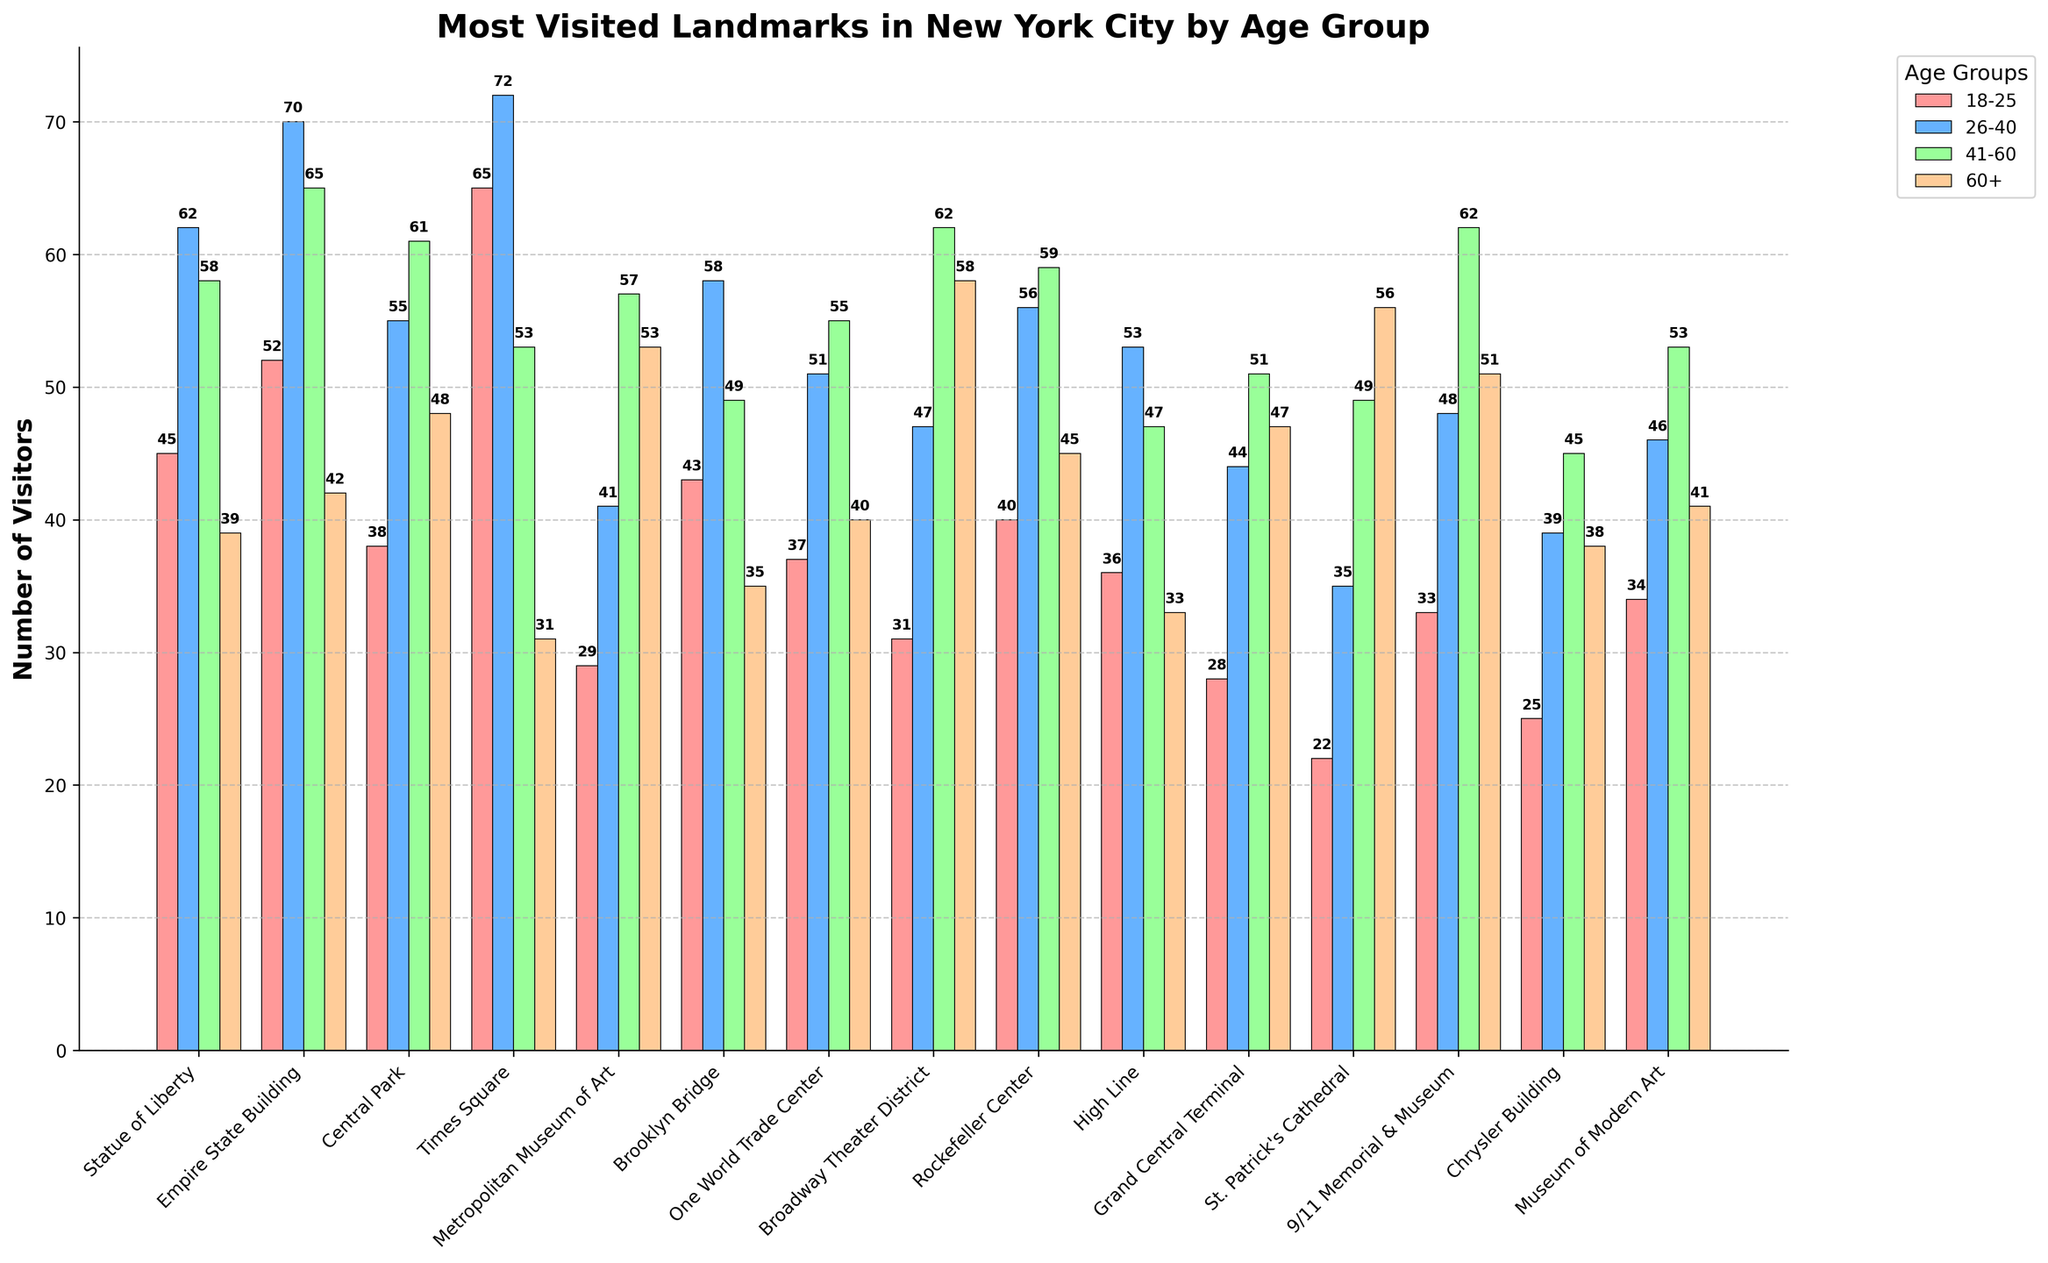What landmark has the highest number of visitors from the age group 18-25? To find the landmark with the highest number of visitors in the 18-25 age group, look for the tallest bar in the red color representing this age group. The highest value is 65 for Times Square.
Answer: Times Square Which age group visits the Statue of Liberty the most? Locate the four bars representing the Statue of Liberty for each age group and compare their heights. The highest bar is blue (26-40) with 62 visitors.
Answer: 26-40 What is the total number of visitors from the age group 41-60 for both Central Park and the Metropolitan Museum of Art? Check the bars corresponding to Central Park and the Metropolitan Museum of Art in the green color (41-60). The counts are 61 and 57 respectively. Summing these gives 61 + 57 = 118.
Answer: 118 How does the number of visitors aged 60+ at the Brooklyn Bridge compare to those at the High Line? Identify the bars representing the 60+ age group for the Brooklyn Bridge and the High Line and compare their heights. The Brooklyn Bridge has 35 visitors, and the High Line has 33. Brooklyn Bridge has 2 more visitors than the High Line.
Answer: Brooklyn Bridge has 2 more visitors Which landmark has the least number of visitors from the 18-25 age group? Find the smallest bar in the red color representing the 18-25 age group. The shortest bar is for St. Patrick's Cathedral with 22 visitors.
Answer: St. Patrick's Cathedral What is the average number of visitors aged 26-40 across Times Square, Empire State Building, and Central Park? Check the bars representing Times Square, Empire State Building, and Central Park for the blue color (26-40). The counts are 72, 70, and 55 respectively. Average is calculated as (72 + 70 + 55) / 3 = 65.67.
Answer: 65.67 Which landmark attracts more visitors aged 60+, Broadway Theater District or One World Trade Center? Locate the bars representing the 60+ age group for both Broadway Theater District and One World Trade Center. The Broadway Theater District has 58 visitors, and One World Trade Center has 40. Broadway Theater District attracts more visitors.
Answer: Broadway Theater District What is the difference in the number of visitors aged 26-40 between Grand Central Terminal and Rockefeller Center? Compare the heights of the bars in the blue color for the Grand Central Terminal and Rockefeller Center. The values are 44 and 56 respectively. The difference is 56 - 44 = 12.
Answer: 12 Which age group has the most number of visitors on average across all landmarks? To find the average number of visitors for each age group, sum the values of visitors for that age group across all landmarks and divide by the number of landmarks (15). Calculate for each age group and compare. This is a complex multi-step calculation.
Answer: 26-40 